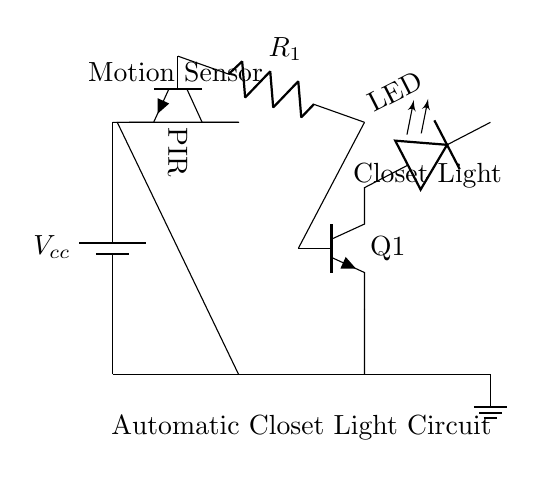What is the purpose of the motion sensor? The motion sensor, indicated as a PIR (Passive Infrared), detects movement to activate the circuit. It's placed in series with the power supply and controls the current flow to the LED when motion is detected.
Answer: Detect motion What does the resistor in the circuit do? The resistor, labeled R1, limits the current flowing into the transistor base to ensure it operates safely and does not get damaged. It helps control the sensitivity of the motion detection.
Answer: Limits current How many power sources are present in this circuit? There is one power source, represented by the battery connected to the circuit. The battery provides the necessary voltage for the circuit to function.
Answer: One power source What component is used to light up the closet? The closet light is represented by the LED in the circuit, which illuminates when the transistor is activated by the motion sensor.
Answer: LED What type of transistor is used in this circuit? The transistor labeled as Q1 is an NPN type, which is a common configuration for switching applications in this context, allowing it to control the LED based on the motion sensor's output.
Answer: NPN What indicates that the circuit is designed for low power applications? The use of low-power components like the LED and the PIR sensor mentioned, along with the small scale of the circuit, suggests it is optimized for efficiency and minimal power consumption.
Answer: Low power components 